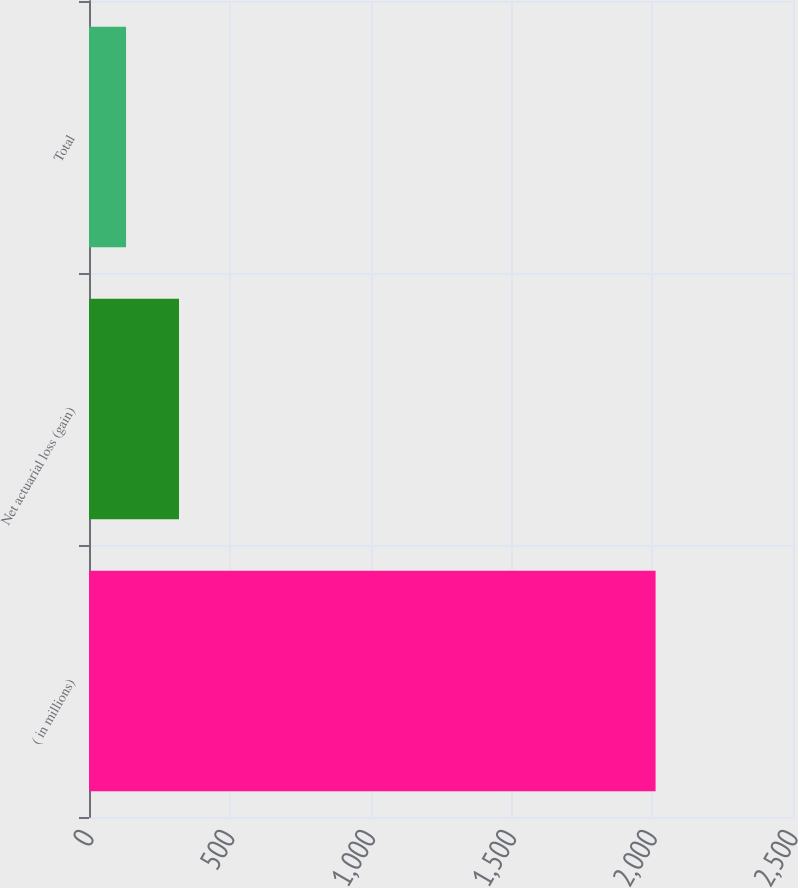Convert chart. <chart><loc_0><loc_0><loc_500><loc_500><bar_chart><fcel>( in millions)<fcel>Net actuarial loss (gain)<fcel>Total<nl><fcel>2012<fcel>319.64<fcel>131.6<nl></chart> 